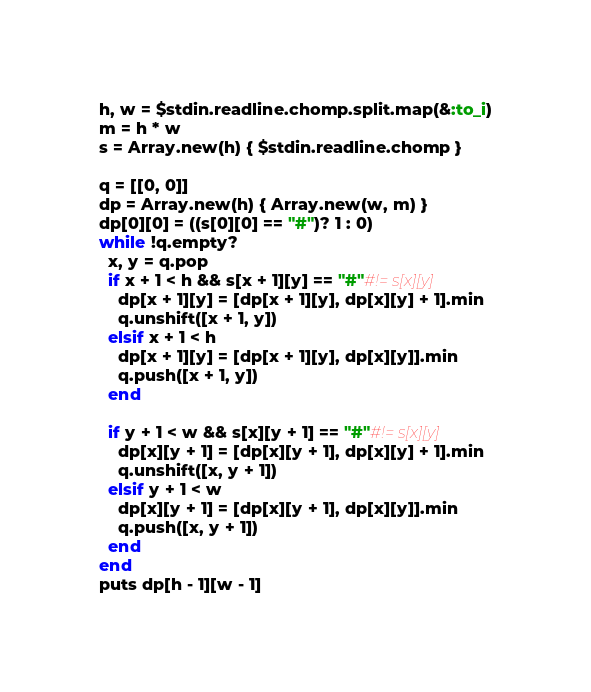Convert code to text. <code><loc_0><loc_0><loc_500><loc_500><_Ruby_>h, w = $stdin.readline.chomp.split.map(&:to_i)
m = h * w
s = Array.new(h) { $stdin.readline.chomp }

q = [[0, 0]]
dp = Array.new(h) { Array.new(w, m) }
dp[0][0] = ((s[0][0] == "#")? 1 : 0)
while !q.empty?
  x, y = q.pop
  if x + 1 < h && s[x + 1][y] == "#"#!= s[x][y]
    dp[x + 1][y] = [dp[x + 1][y], dp[x][y] + 1].min
    q.unshift([x + 1, y])
  elsif x + 1 < h
    dp[x + 1][y] = [dp[x + 1][y], dp[x][y]].min
    q.push([x + 1, y])
  end

  if y + 1 < w && s[x][y + 1] == "#"#!= s[x][y]
    dp[x][y + 1] = [dp[x][y + 1], dp[x][y] + 1].min
    q.unshift([x, y + 1])
  elsif y + 1 < w
    dp[x][y + 1] = [dp[x][y + 1], dp[x][y]].min
    q.push([x, y + 1])
  end
end
puts dp[h - 1][w - 1]</code> 